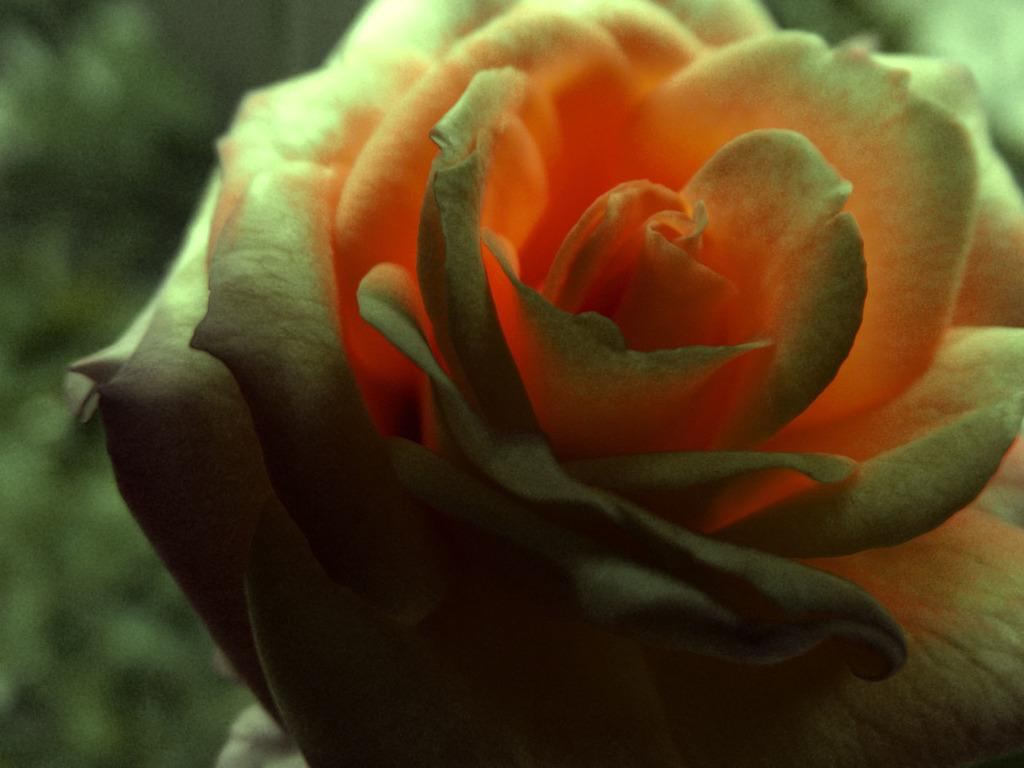What type of flower is in the image? There is a cream and orange color rose in the image. What type of flag is visible in the image? There is no flag present in the image; it features a cream and orange color rose. What is the chance of winning a card game in the image? There is no card game or mention of winning in the image; it features a cream and orange color rose. 